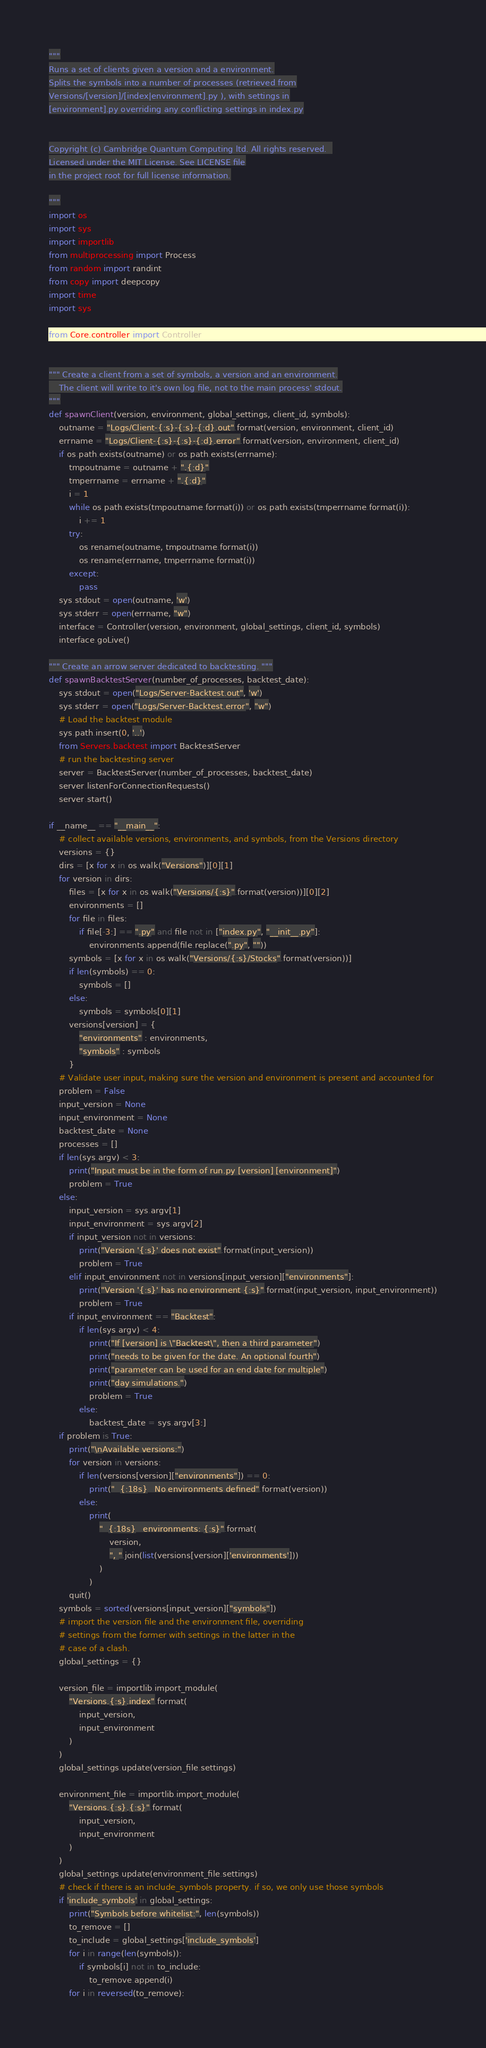<code> <loc_0><loc_0><loc_500><loc_500><_Python_>"""
Runs a set of clients given a version and a environment.
Splits the symbols into a number of processes (retrieved from
Versions/[version]/[index|environment].py ), with settings in
[environment].py overriding any conflicting settings in index.py


Copyright (c) Cambridge Quantum Computing ltd. All rights reserved.  
Licensed under the MIT License. See LICENSE file
in the project root for full license information.

"""
import os
import sys
import importlib
from multiprocessing import Process
from random import randint
from copy import deepcopy
import time
import sys

from Core.controller import Controller


""" Create a client from a set of symbols, a version and an environment.
    The client will write to it's own log file, not to the main process' stdout.
"""
def spawnClient(version, environment, global_settings, client_id, symbols):
    outname = "Logs/Client-{:s}-{:s}-{:d}.out".format(version, environment, client_id)
    errname = "Logs/Client-{:s}-{:s}-{:d}.error".format(version, environment, client_id)
    if os.path.exists(outname) or os.path.exists(errname):
        tmpoutname = outname + ".{:d}"
        tmperrname = errname + ".{:d}"
        i = 1
        while os.path.exists(tmpoutname.format(i)) or os.path.exists(tmperrname.format(i)):
            i += 1
        try:
            os.rename(outname, tmpoutname.format(i))
            os.rename(errname, tmperrname.format(i))
        except:
            pass
    sys.stdout = open(outname, 'w')
    sys.stderr = open(errname, "w")
    interface = Controller(version, environment, global_settings, client_id, symbols)
    interface.goLive()

""" Create an arrow server dedicated to backtesting. """
def spawnBacktestServer(number_of_processes, backtest_date):
    sys.stdout = open("Logs/Server-Backtest.out", 'w')
    sys.stderr = open("Logs/Server-Backtest.error", "w")
    # Load the backtest module
    sys.path.insert(0, '..')
    from Servers.backtest import BacktestServer
    # run the backtesting server
    server = BacktestServer(number_of_processes, backtest_date)
    server.listenForConnectionRequests()
    server.start()

if __name__ == "__main__":
    # collect available versions, environments, and symbols, from the Versions directory
    versions = {}
    dirs = [x for x in os.walk("Versions")][0][1]
    for version in dirs:
        files = [x for x in os.walk("Versions/{:s}".format(version))][0][2]
        environments = []
        for file in files:
            if file[-3:] == ".py" and file not in ["index.py", "__init__.py"]:
                environments.append(file.replace(".py", ""))
        symbols = [x for x in os.walk("Versions/{:s}/Stocks".format(version))]
        if len(symbols) == 0:
            symbols = []
        else:
            symbols = symbols[0][1]
        versions[version] = {
            "environments" : environments,
            "symbols" : symbols
        }
    # Validate user input, making sure the version and environment is present and accounted for
    problem = False
    input_version = None
    input_environment = None
    backtest_date = None
    processes = []
    if len(sys.argv) < 3:
        print("Input must be in the form of run.py [version] [environment]")
        problem = True
    else:
        input_version = sys.argv[1]
        input_environment = sys.argv[2]
        if input_version not in versions:
            print("Version '{:s}' does not exist".format(input_version))
            problem = True
        elif input_environment not in versions[input_version]["environments"]:
            print("Version '{:s}' has no environment {:s}".format(input_version, input_environment))
            problem = True
        if input_environment == "Backtest":
            if len(sys.argv) < 4:
                print("If [version] is \"Backtest\", then a third parameter")
                print("needs to be given for the date. An optional fourth")
                print("parameter can be used for an end date for multiple")
                print("day simulations.")
                problem = True
            else:
                backtest_date = sys.argv[3:]
    if problem is True:
        print("\nAvailable versions:")
        for version in versions:
            if len(versions[version]["environments"]) == 0:
                print("  {:18s}   No environments defined".format(version))
            else:
                print(
                    "  {:18s}   environments: {:s}".format(
                        version,
                        ", ".join(list(versions[version]['environments']))
                    )
                )
        quit()
    symbols = sorted(versions[input_version]["symbols"])
    # import the version file and the environment file, overriding
    # settings from the former with settings in the latter in the
    # case of a clash.
    global_settings = {}

    version_file = importlib.import_module(
        "Versions.{:s}.index".format(
            input_version,
            input_environment
        )
    )
    global_settings.update(version_file.settings)

    environment_file = importlib.import_module(
        "Versions.{:s}.{:s}".format(
            input_version,
            input_environment
        )
    )
    global_settings.update(environment_file.settings)
    # check if there is an include_symbols property. if so, we only use those symbols
    if 'include_symbols' in global_settings:
        print("Symbols before whitelist:", len(symbols))
        to_remove = []
        to_include = global_settings['include_symbols']
        for i in range(len(symbols)):
            if symbols[i] not in to_include:
                to_remove.append(i)
        for i in reversed(to_remove):</code> 